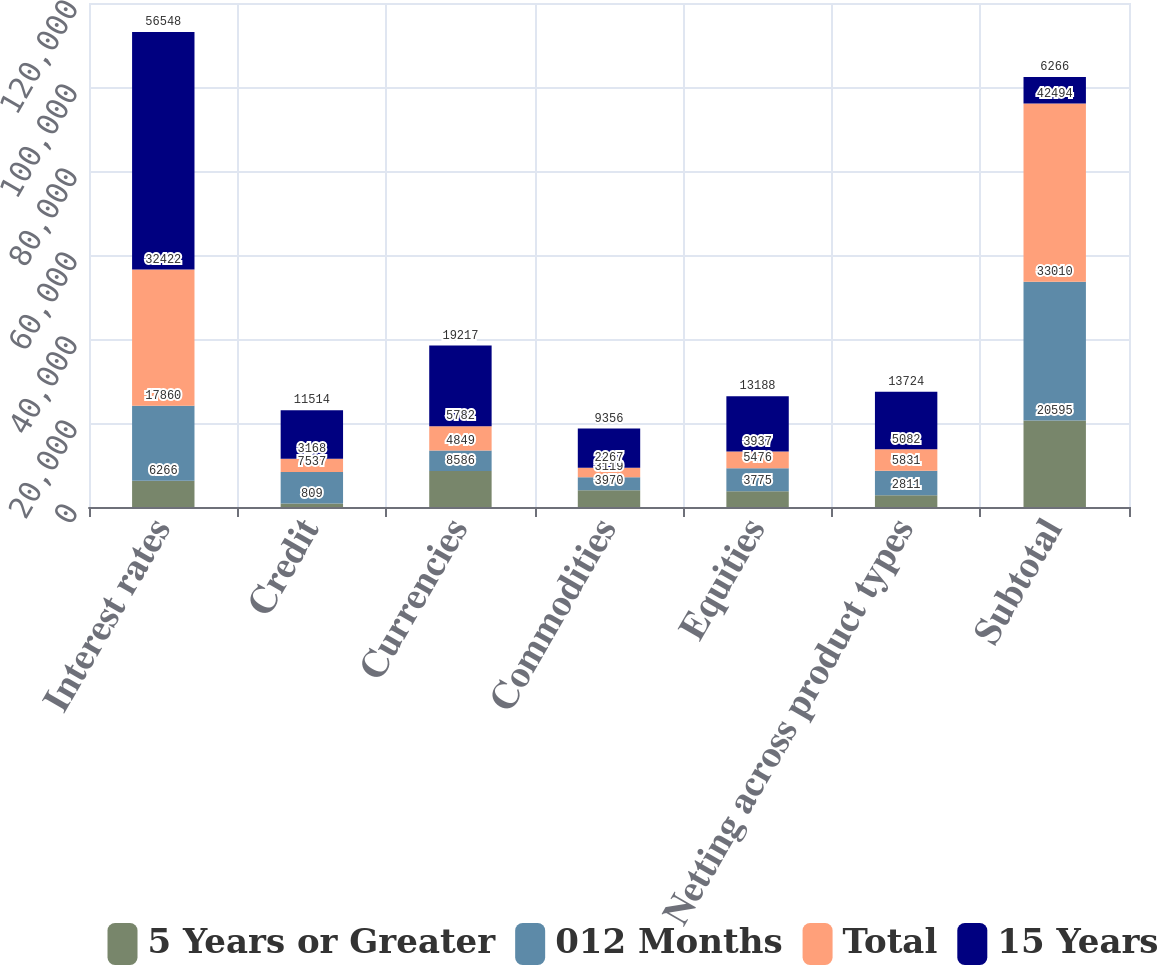Convert chart to OTSL. <chart><loc_0><loc_0><loc_500><loc_500><stacked_bar_chart><ecel><fcel>Interest rates<fcel>Credit<fcel>Currencies<fcel>Commodities<fcel>Equities<fcel>Netting across product types<fcel>Subtotal<nl><fcel>5 Years or Greater<fcel>6266<fcel>809<fcel>8586<fcel>3970<fcel>3775<fcel>2811<fcel>20595<nl><fcel>012 Months<fcel>17860<fcel>7537<fcel>4849<fcel>3119<fcel>5476<fcel>5831<fcel>33010<nl><fcel>Total<fcel>32422<fcel>3168<fcel>5782<fcel>2267<fcel>3937<fcel>5082<fcel>42494<nl><fcel>15 Years<fcel>56548<fcel>11514<fcel>19217<fcel>9356<fcel>13188<fcel>13724<fcel>6266<nl></chart> 